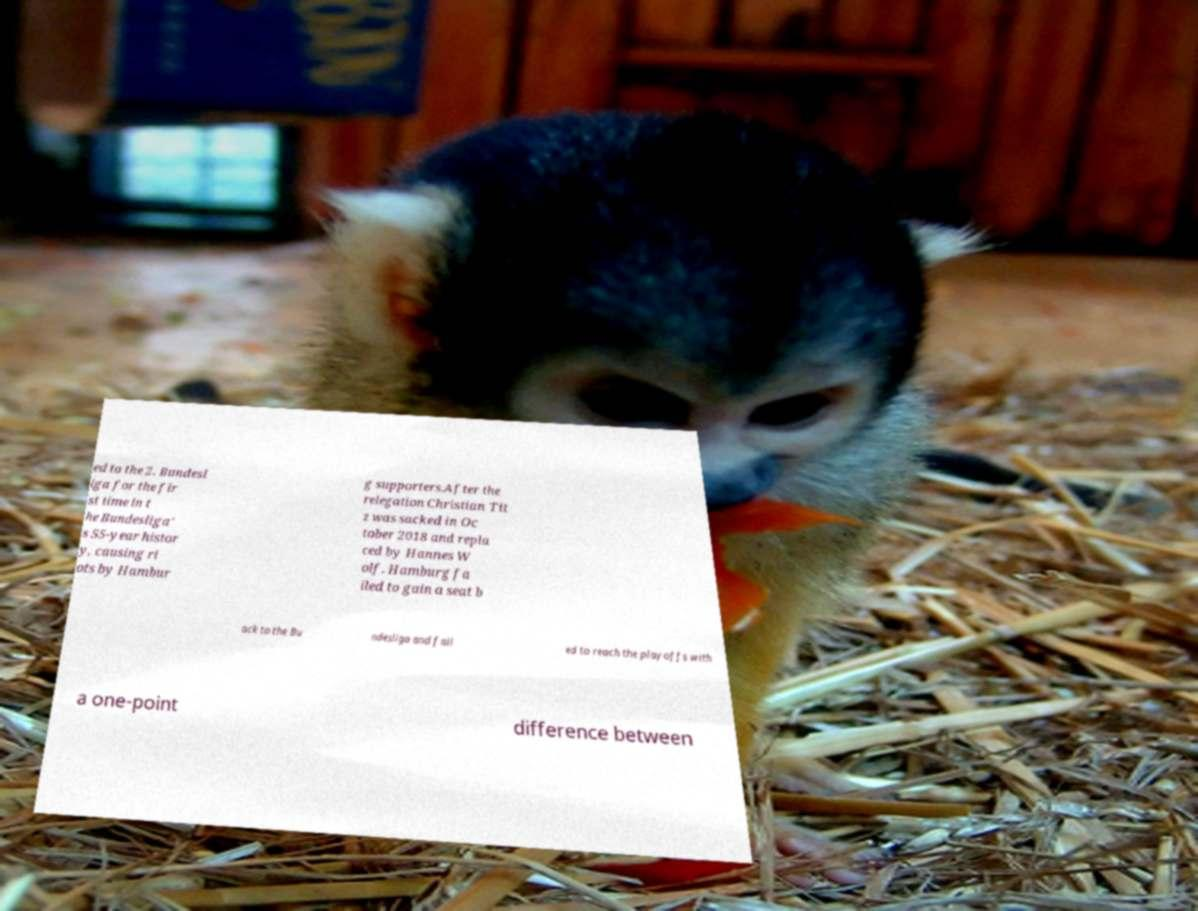Could you extract and type out the text from this image? ed to the 2. Bundesl iga for the fir st time in t he Bundesliga' s 55-year histor y, causing ri ots by Hambur g supporters.After the relegation Christian Tit z was sacked in Oc tober 2018 and repla ced by Hannes W olf. Hamburg fa iled to gain a seat b ack to the Bu ndesliga and fail ed to reach the playoffs with a one-point difference between 